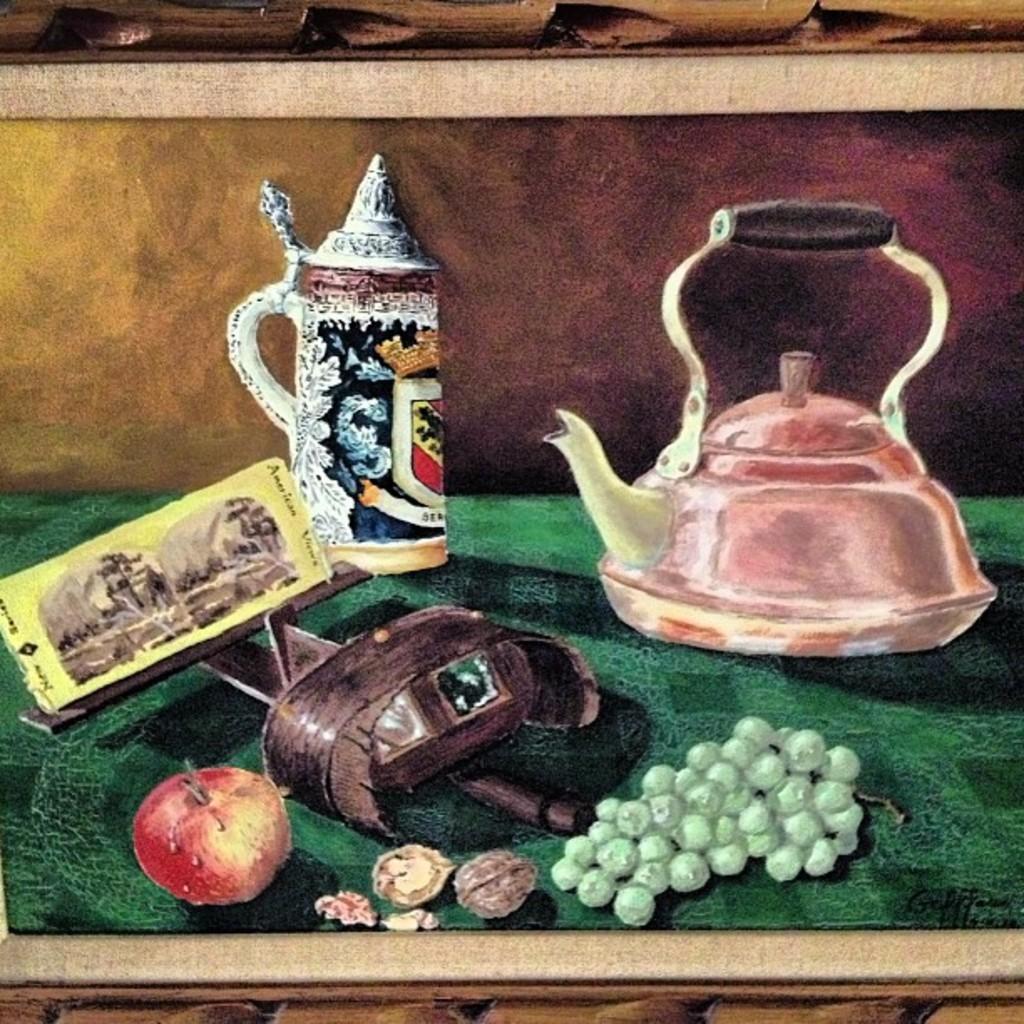Can you describe this image briefly? I see this is an animated picture and I see an apple, grapes, a bottle, a kettle and few things and these all things are on a green colors surface and it is brown and maroon over here. 